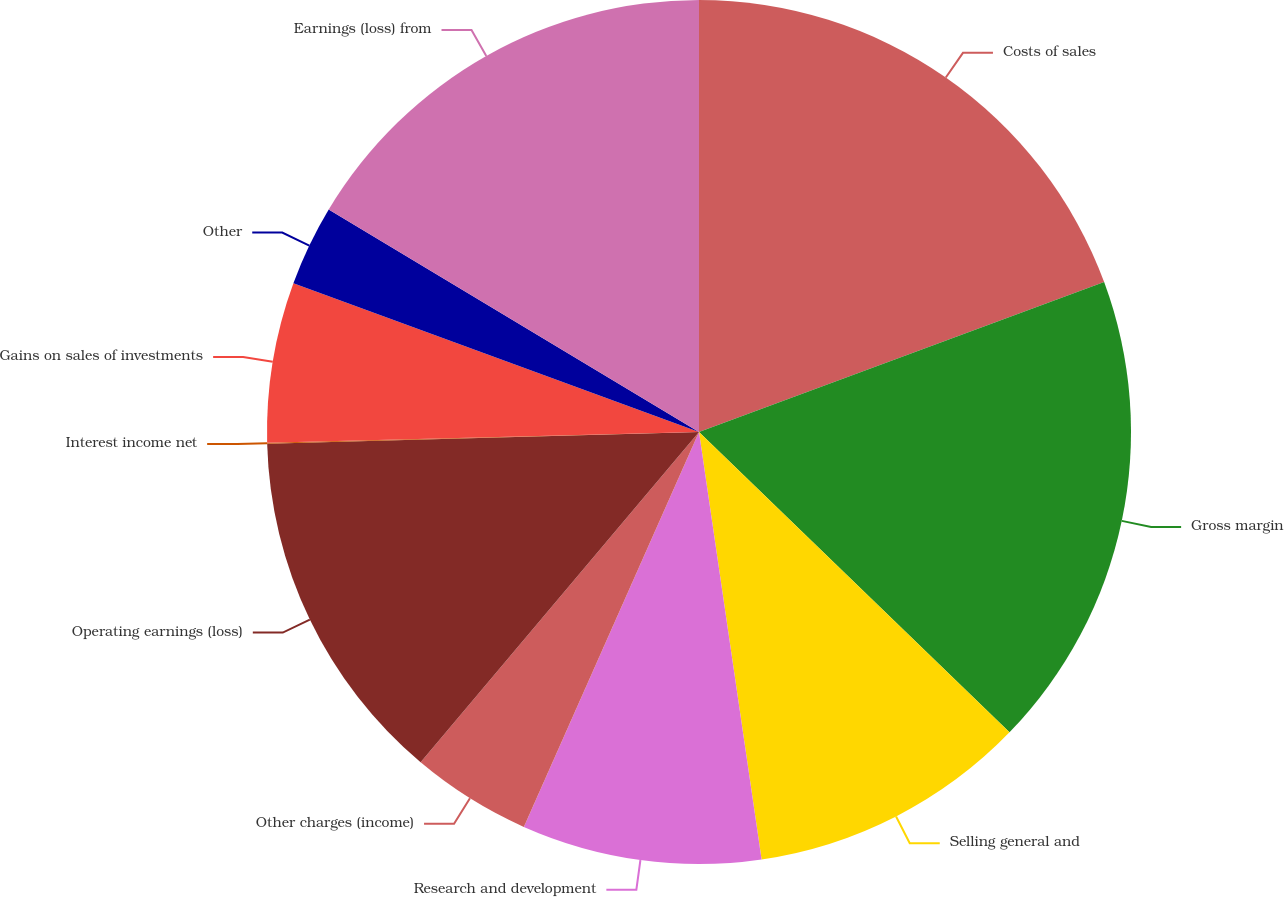Convert chart to OTSL. <chart><loc_0><loc_0><loc_500><loc_500><pie_chart><fcel>Costs of sales<fcel>Gross margin<fcel>Selling general and<fcel>Research and development<fcel>Other charges (income)<fcel>Operating earnings (loss)<fcel>Interest income net<fcel>Gains on sales of investments<fcel>Other<fcel>Earnings (loss) from<nl><fcel>19.36%<fcel>17.88%<fcel>10.45%<fcel>8.96%<fcel>4.5%<fcel>13.42%<fcel>0.04%<fcel>5.99%<fcel>3.02%<fcel>16.39%<nl></chart> 